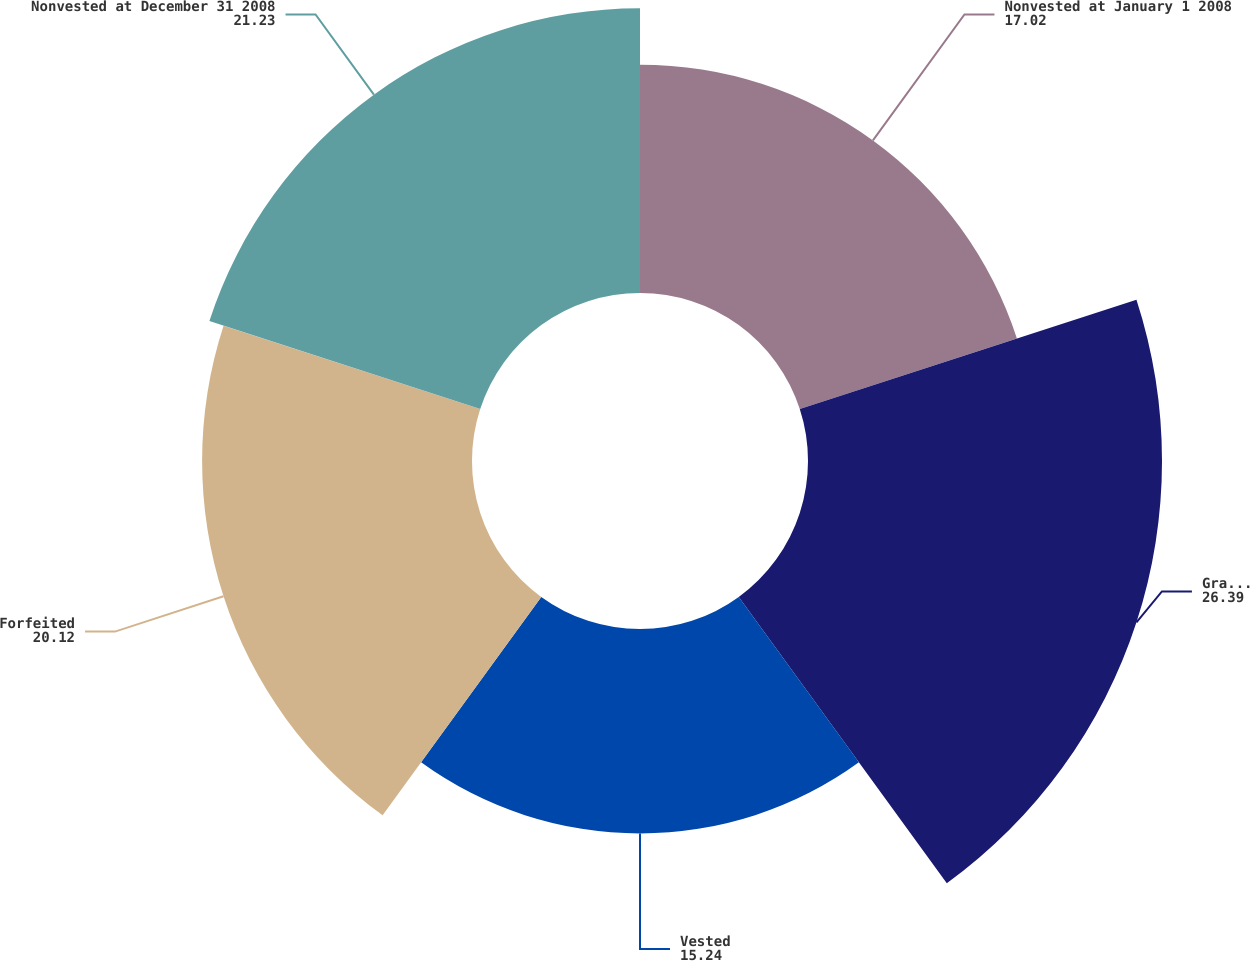Convert chart to OTSL. <chart><loc_0><loc_0><loc_500><loc_500><pie_chart><fcel>Nonvested at January 1 2008<fcel>Granted<fcel>Vested<fcel>Forfeited<fcel>Nonvested at December 31 2008<nl><fcel>17.02%<fcel>26.39%<fcel>15.24%<fcel>20.12%<fcel>21.23%<nl></chart> 